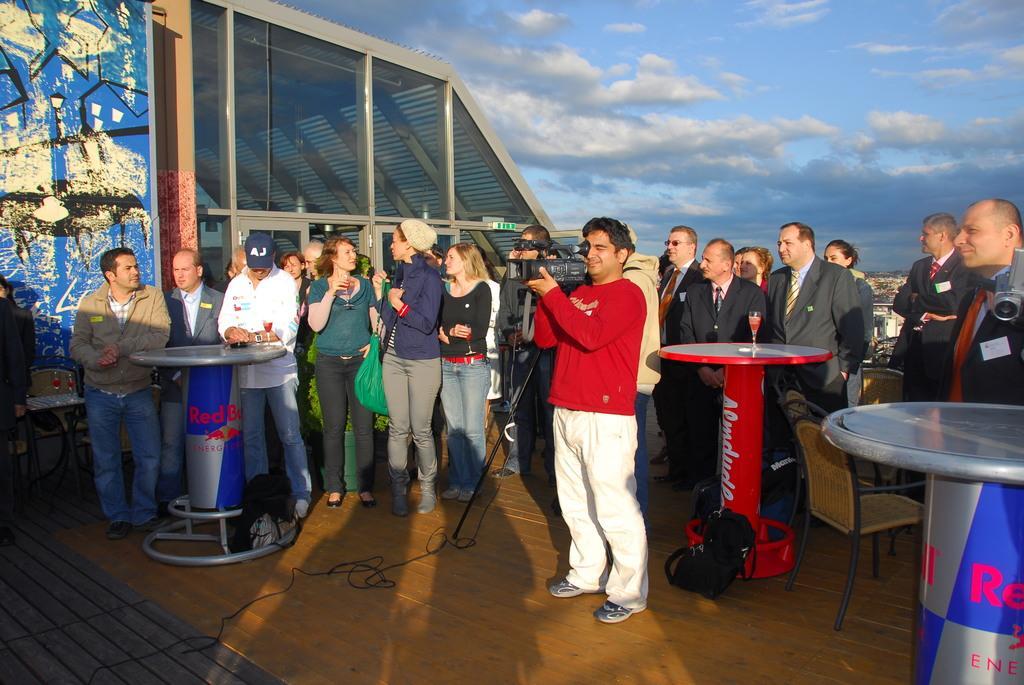Describe this image in one or two sentences. The image consists of number of people in which one of the person is holding a camera and shooting the video. There is another man to the left side who is near the table. At the top there is a sunny sky. At the background there is a wall which has design on it. 